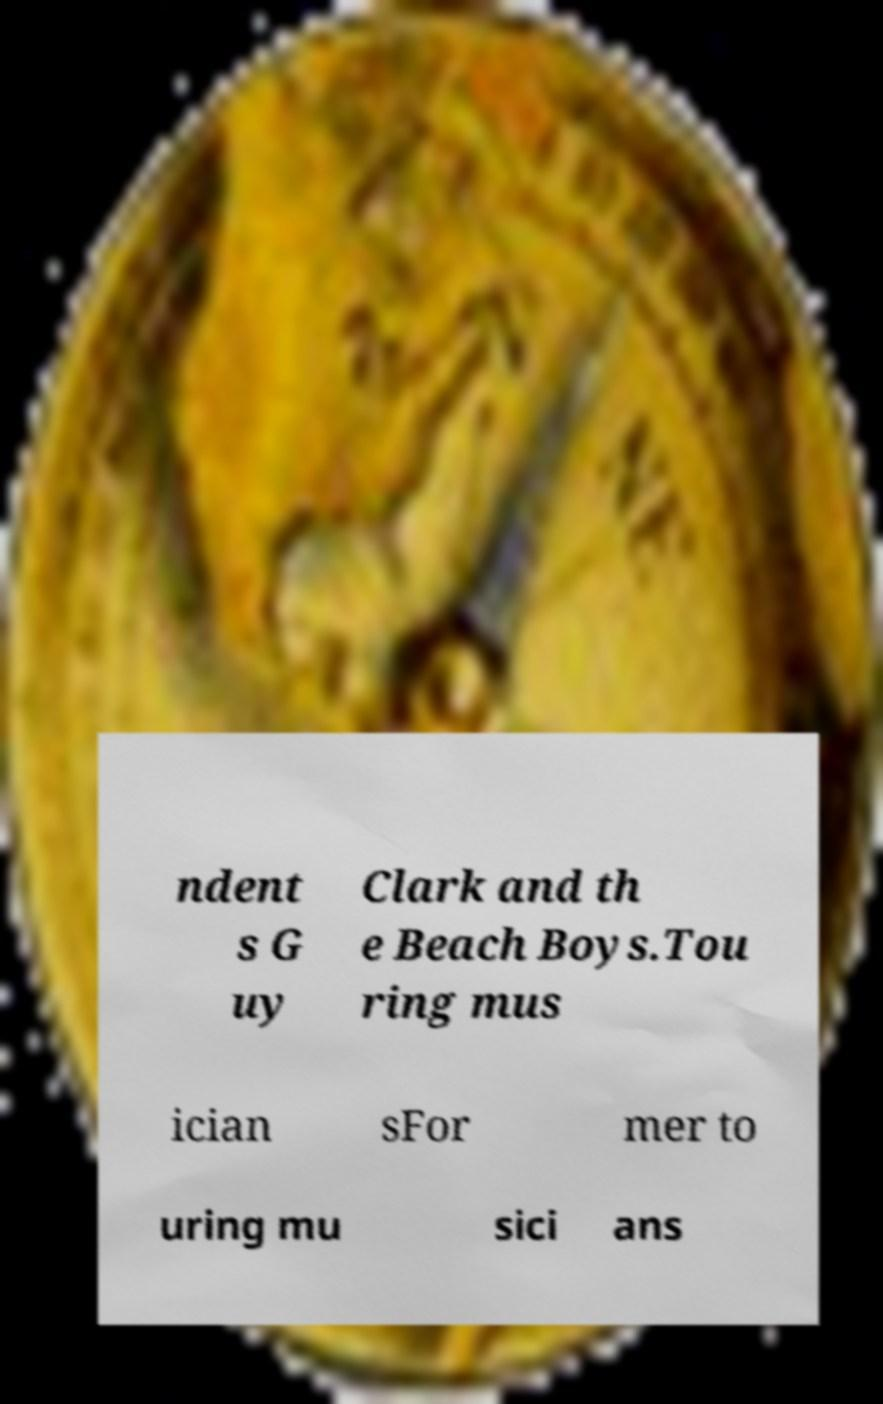Please identify and transcribe the text found in this image. ndent s G uy Clark and th e Beach Boys.Tou ring mus ician sFor mer to uring mu sici ans 